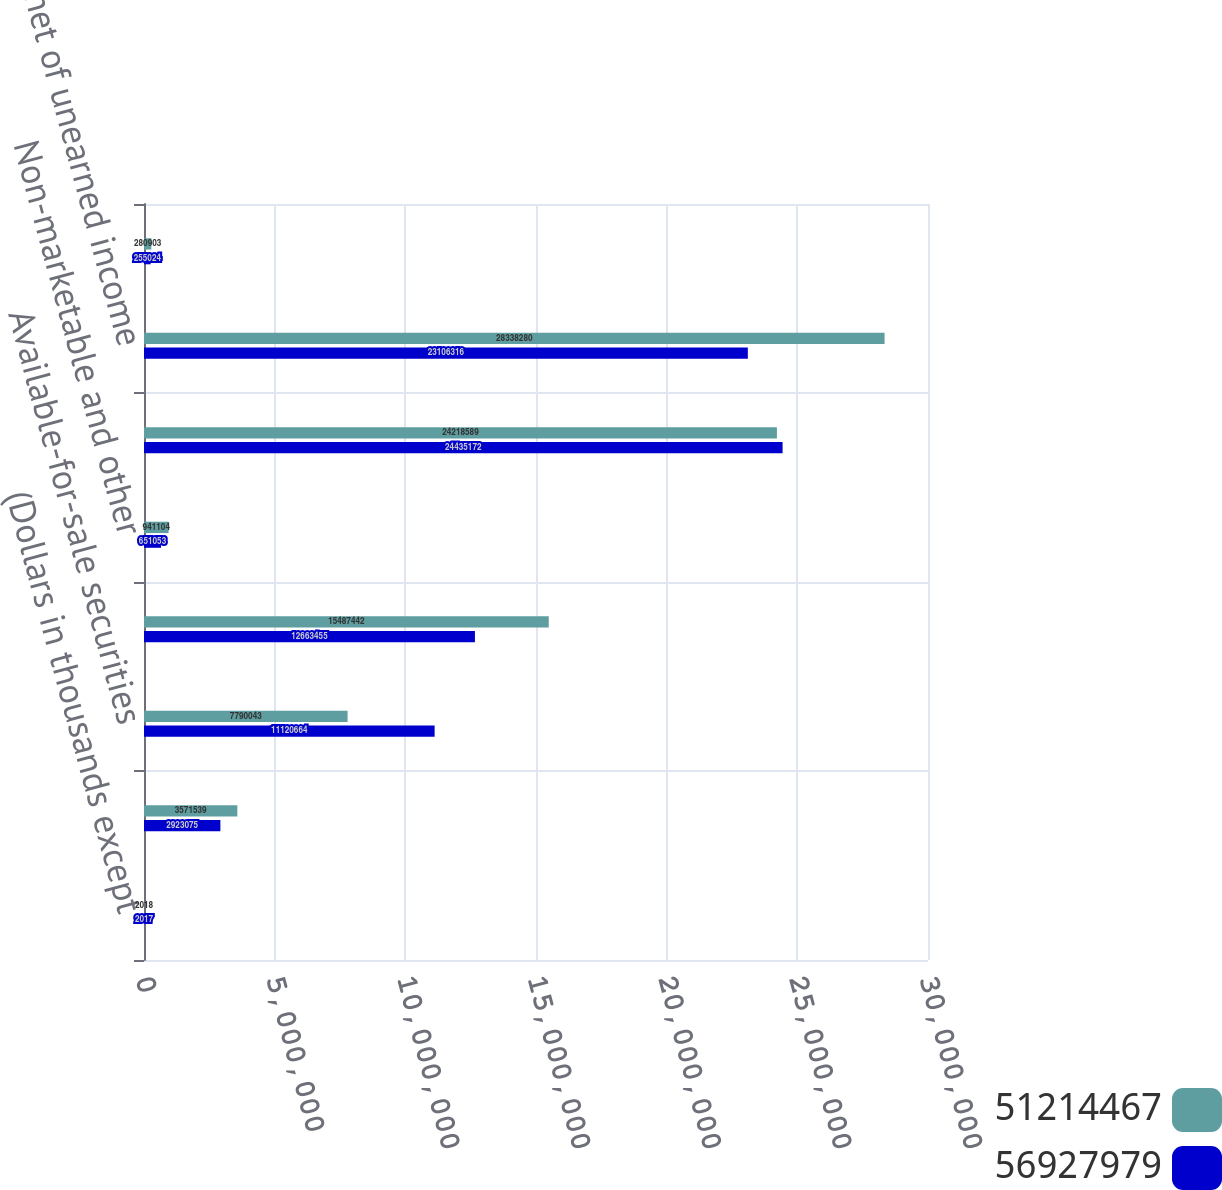Convert chart. <chart><loc_0><loc_0><loc_500><loc_500><stacked_bar_chart><ecel><fcel>(Dollars in thousands except<fcel>Cash and cash equivalents<fcel>Available-for-sale securities<fcel>Held-to-maturity securities at<fcel>Non-marketable and other<fcel>Total investment securities<fcel>Loans net of unearned income<fcel>Allowance for loan losses<nl><fcel>5.12145e+07<fcel>2018<fcel>3.57154e+06<fcel>7.79004e+06<fcel>1.54874e+07<fcel>941104<fcel>2.42186e+07<fcel>2.83383e+07<fcel>280903<nl><fcel>5.6928e+07<fcel>2017<fcel>2.92308e+06<fcel>1.11207e+07<fcel>1.26635e+07<fcel>651053<fcel>2.44352e+07<fcel>2.31063e+07<fcel>255024<nl></chart> 